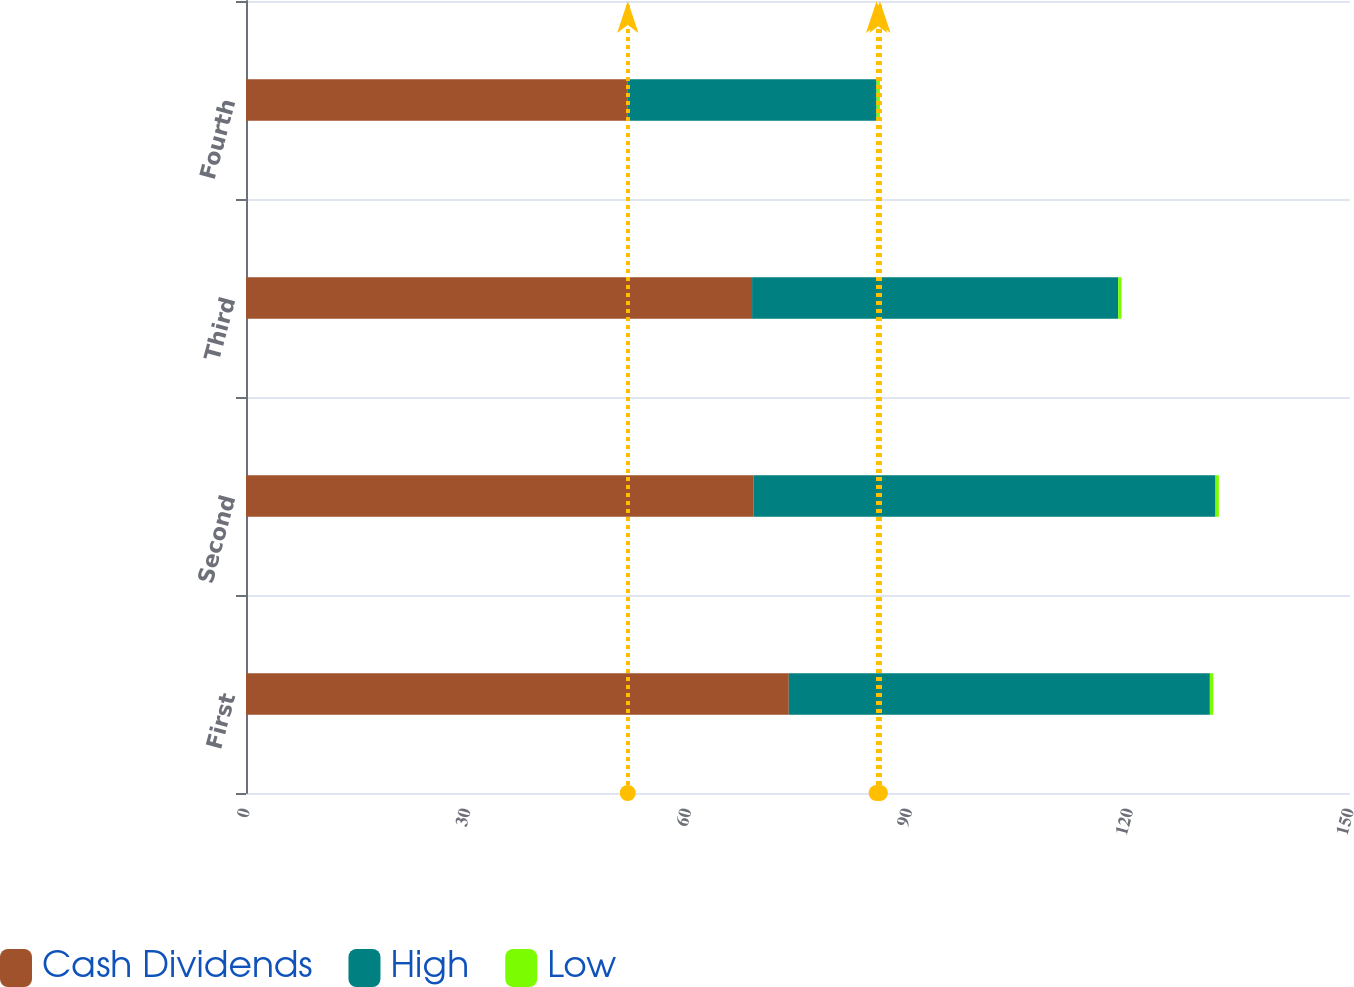<chart> <loc_0><loc_0><loc_500><loc_500><stacked_bar_chart><ecel><fcel>First<fcel>Second<fcel>Third<fcel>Fourth<nl><fcel>Cash Dividends<fcel>73.75<fcel>68.98<fcel>68.76<fcel>51.87<nl><fcel>High<fcel>57.21<fcel>62.75<fcel>49.74<fcel>33.81<nl><fcel>Low<fcel>0.45<fcel>0.45<fcel>0.45<fcel>0.45<nl></chart> 